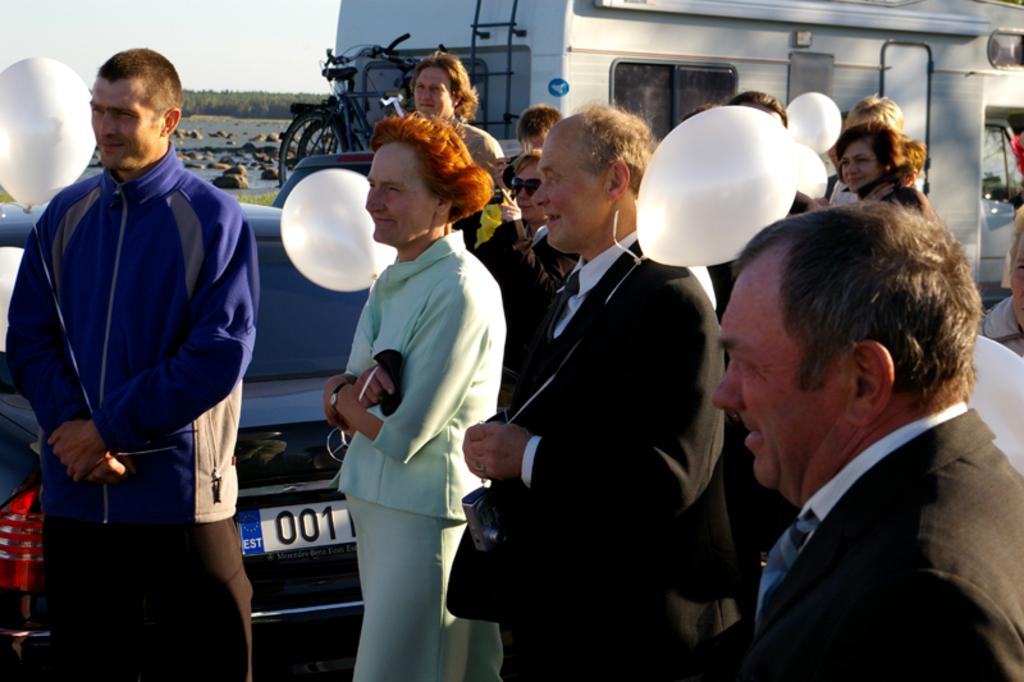How many people are in the image? There is a group of people in the image, but the exact number is not specified. What are the people doing in the image? The people are standing in the image. What are the people holding in their hands? The people are holding balloons in their hands. What can be seen in the background of the image? There is a vehicle, a bicycle, rocks, and the sky visible in the background of the image. What type of fire can be seen in the image? There is no fire present in the image. How many pigs are visible in the image? There are no pigs present in the image. 